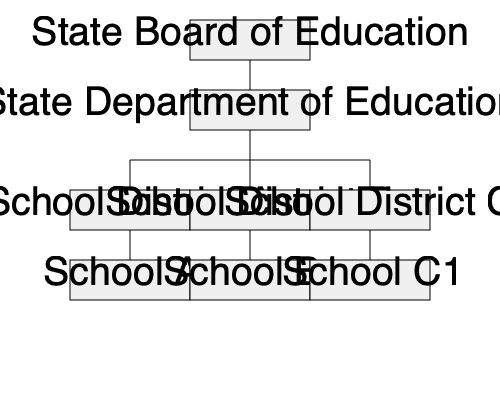Based on the organizational chart of the educational system shown, which entity has direct authority over individual schools but is subordinate to the State Department of Education? To answer this question, let's analyze the hierarchical structure presented in the organizational chart:

1. At the top of the hierarchy is the State Board of Education.
2. Directly below it is the State Department of Education.
3. The next level shows three entities: School District A, School District B, and School District C.
4. At the bottom of the hierarchy are individual schools (School A1, School B1, School C1).

The key points to consider are:

a) The State Department of Education is directly below the State Board of Education, indicating it's subordinate to the Board but has authority over the entities below it.

b) School Districts (A, B, and C) are positioned between the State Department of Education and individual schools.

c) Individual schools are at the bottom of the hierarchy, suggesting they are under the direct authority of the entities above them.

Given this structure, we can conclude that School Districts have direct authority over individual schools (as they are immediately above them in the hierarchy) but are subordinate to the State Department of Education (as they are positioned below it in the chart).
Answer: School Districts 